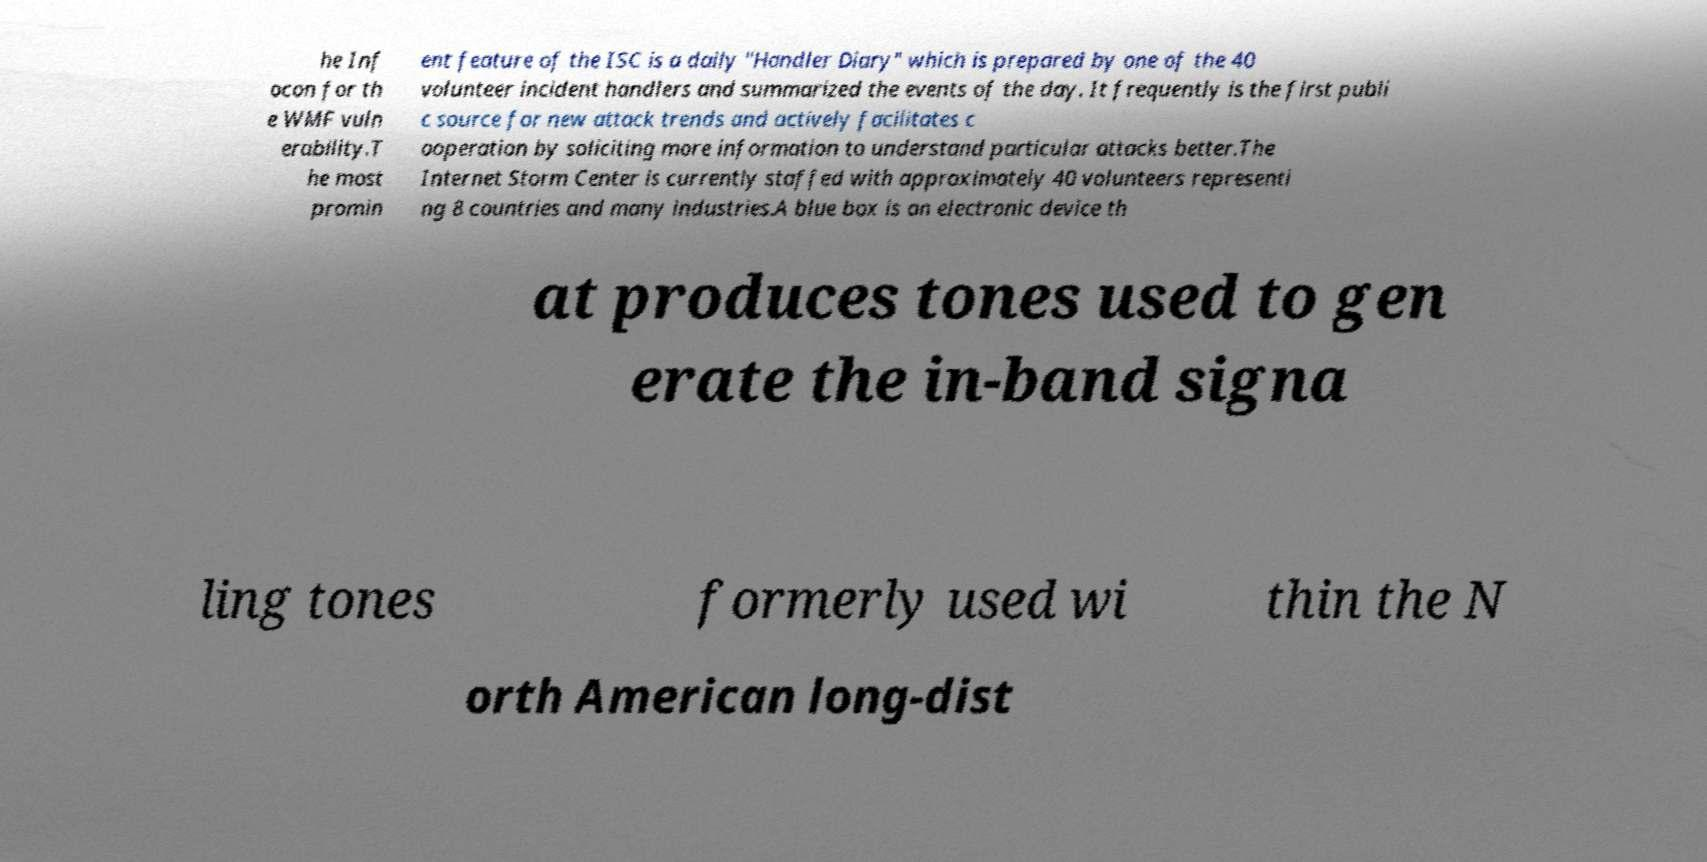Could you extract and type out the text from this image? he Inf ocon for th e WMF vuln erability.T he most promin ent feature of the ISC is a daily "Handler Diary" which is prepared by one of the 40 volunteer incident handlers and summarized the events of the day. It frequently is the first publi c source for new attack trends and actively facilitates c ooperation by soliciting more information to understand particular attacks better.The Internet Storm Center is currently staffed with approximately 40 volunteers representi ng 8 countries and many industries.A blue box is an electronic device th at produces tones used to gen erate the in-band signa ling tones formerly used wi thin the N orth American long-dist 